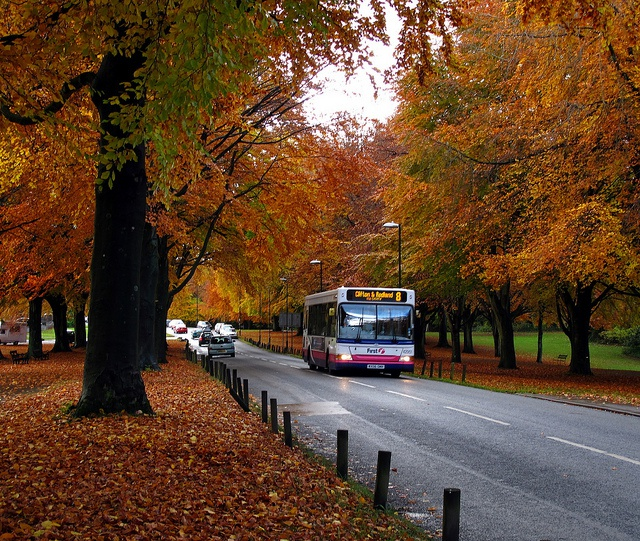Describe the objects in this image and their specific colors. I can see bus in maroon, black, gray, and darkgray tones, car in maroon, black, gray, darkblue, and blue tones, car in maroon, black, gray, darkgray, and lightgray tones, car in maroon, white, darkgray, and gray tones, and car in maroon, white, darkgray, gray, and black tones in this image. 